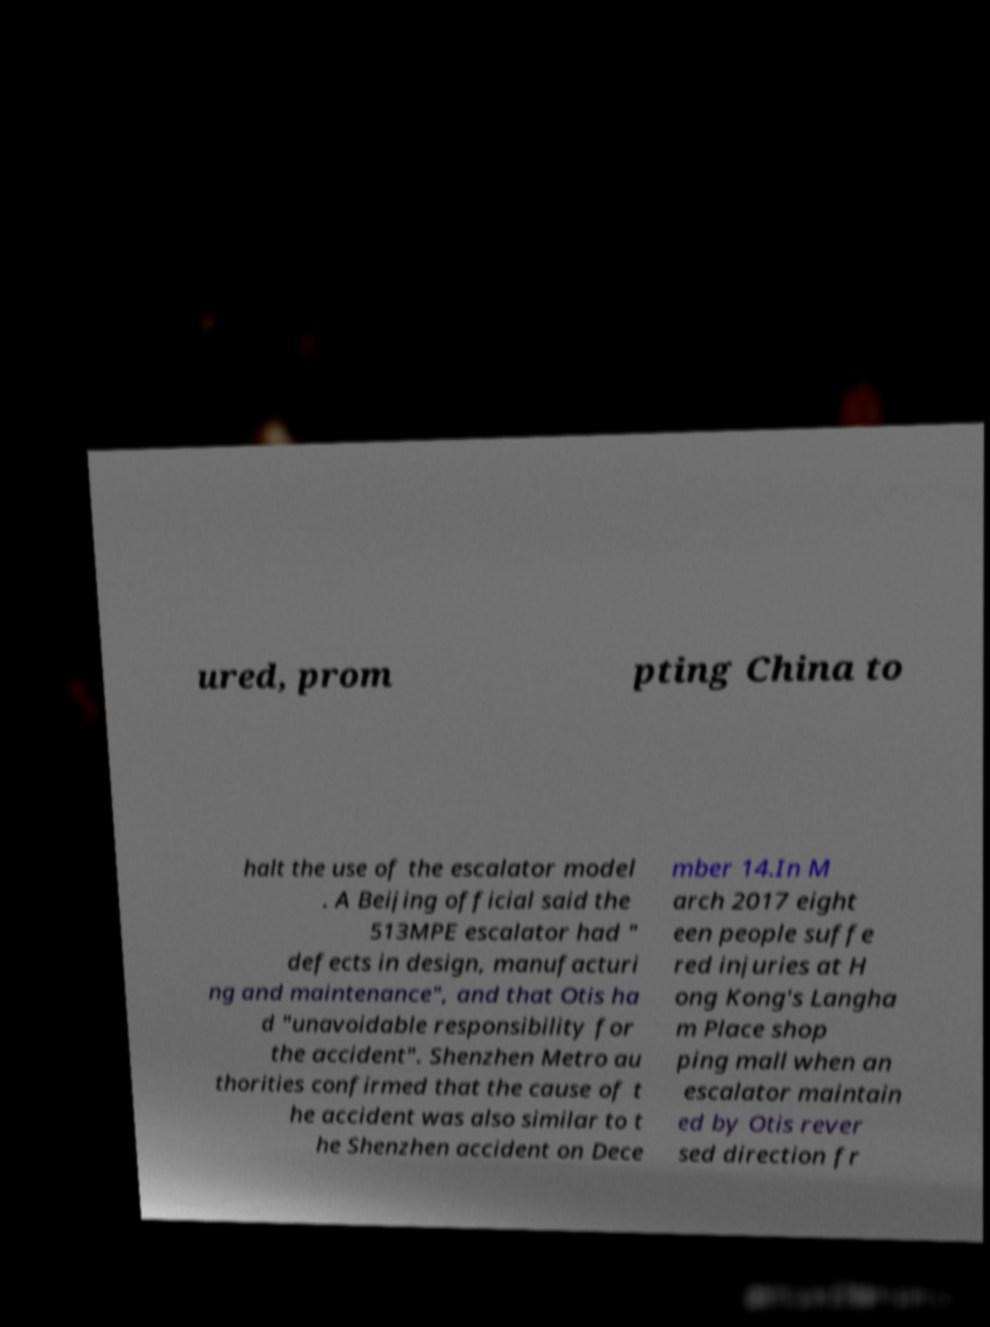Could you extract and type out the text from this image? ured, prom pting China to halt the use of the escalator model . A Beijing official said the 513MPE escalator had " defects in design, manufacturi ng and maintenance", and that Otis ha d "unavoidable responsibility for the accident". Shenzhen Metro au thorities confirmed that the cause of t he accident was also similar to t he Shenzhen accident on Dece mber 14.In M arch 2017 eight een people suffe red injuries at H ong Kong's Langha m Place shop ping mall when an escalator maintain ed by Otis rever sed direction fr 